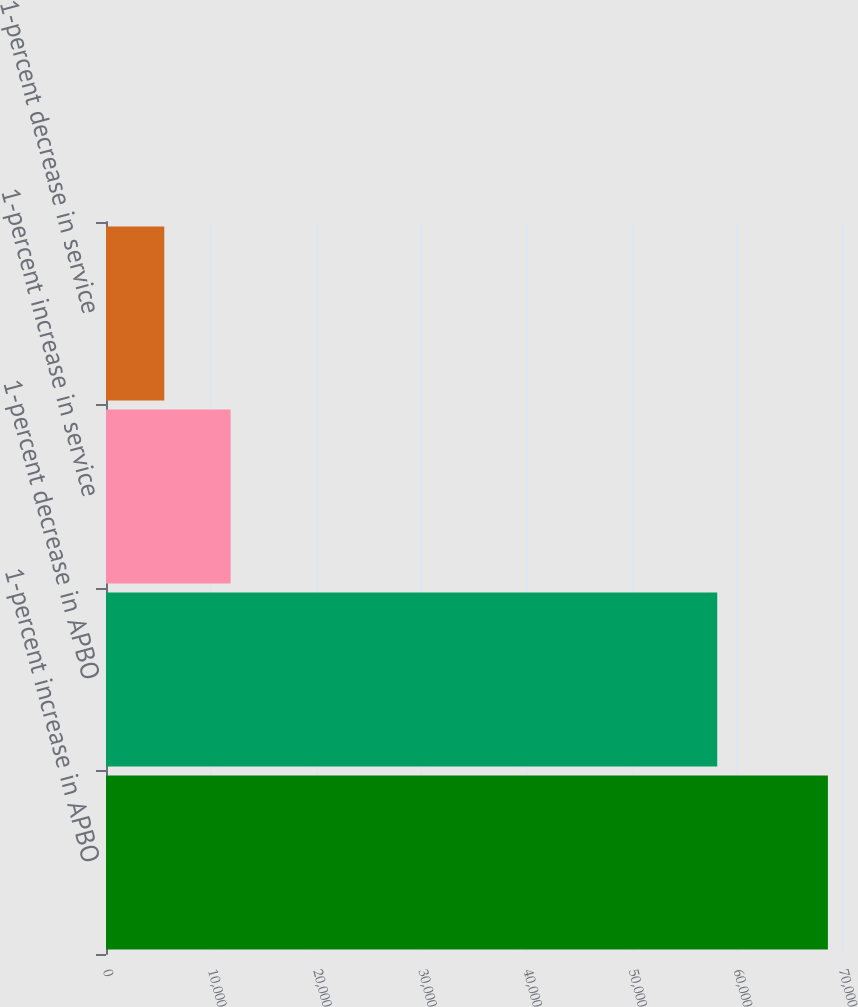Convert chart to OTSL. <chart><loc_0><loc_0><loc_500><loc_500><bar_chart><fcel>1-percent increase in APBO<fcel>1-percent decrease in APBO<fcel>1-percent increase in service<fcel>1-percent decrease in service<nl><fcel>68659<fcel>58133<fcel>11853.7<fcel>5542<nl></chart> 